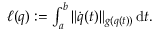Convert formula to latex. <formula><loc_0><loc_0><loc_500><loc_500>\begin{array} { r } { \ell ( q ) \colon = \int _ { a } ^ { b } \| \dot { q } ( t ) \| _ { g ( q ( t ) ) } \, d t . } \end{array}</formula> 